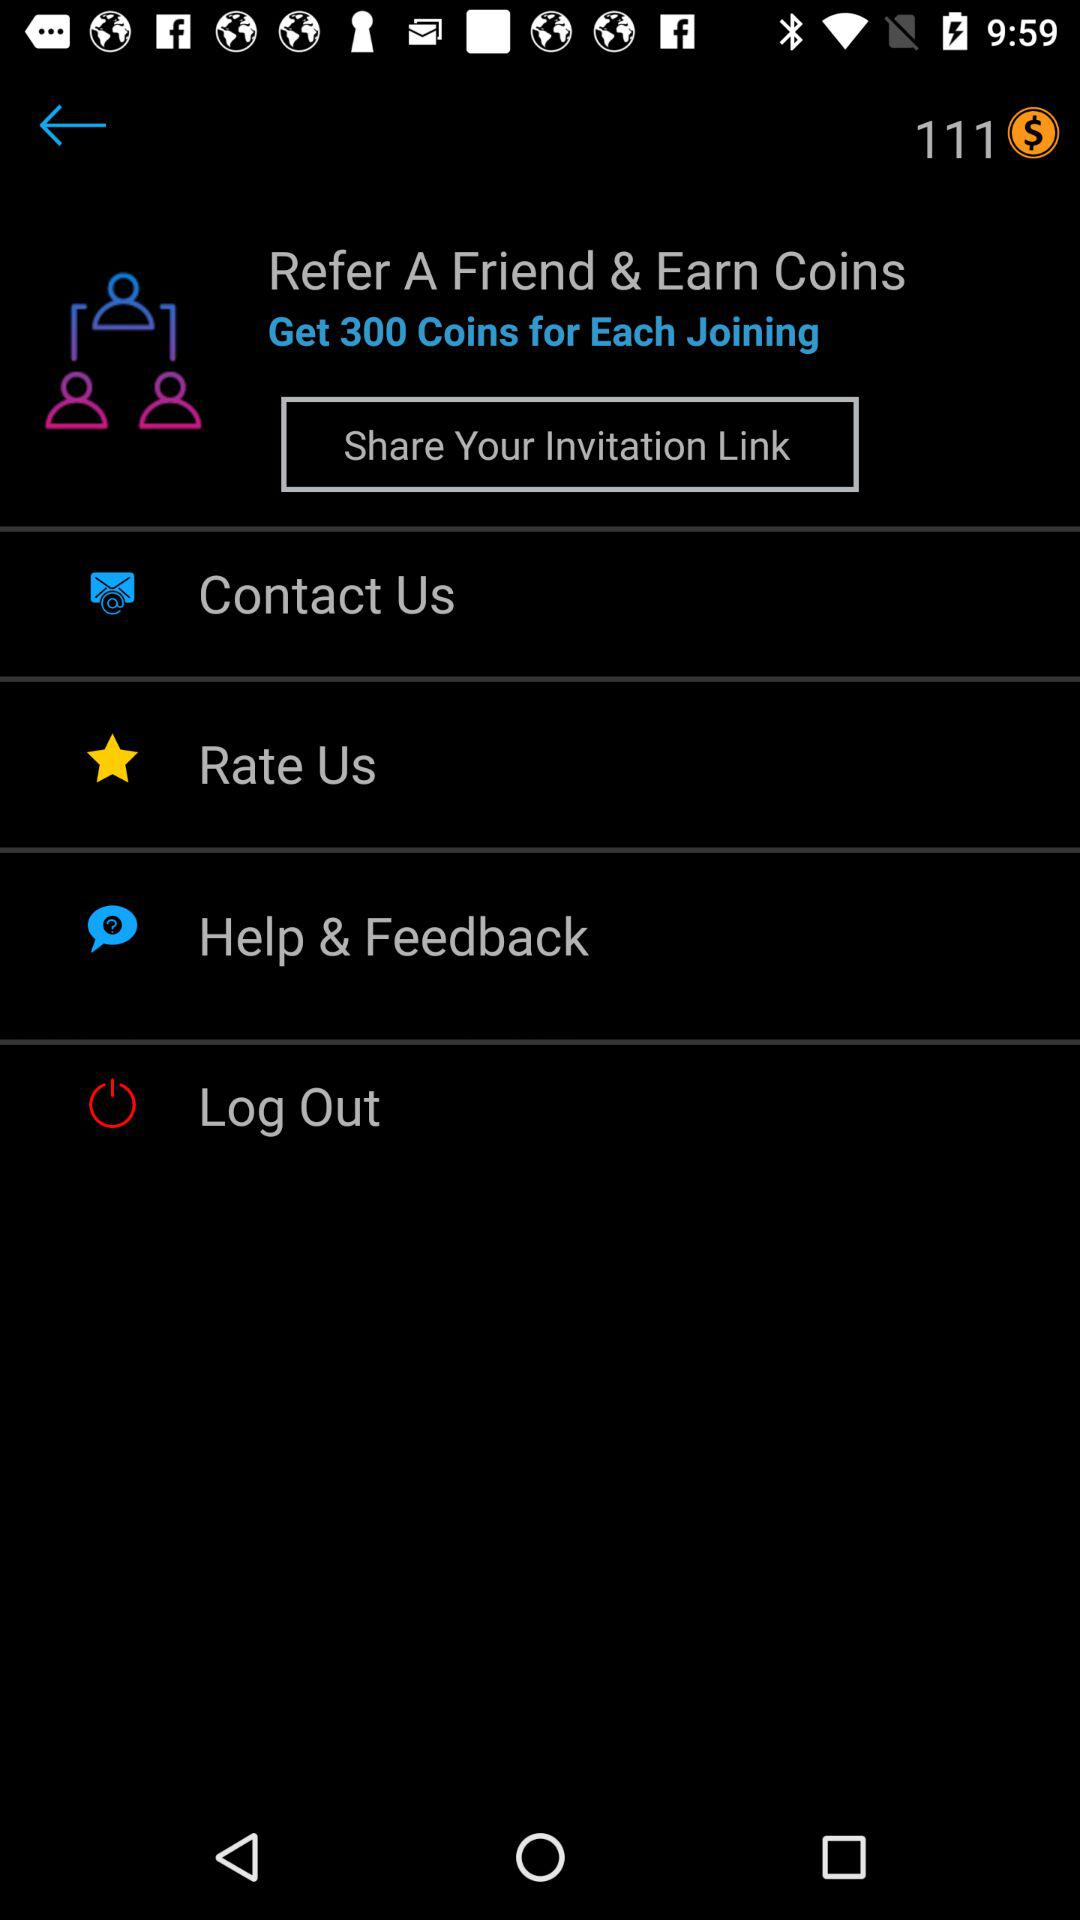How many coins do you get for each person that joins?
Answer the question using a single word or phrase. 300 